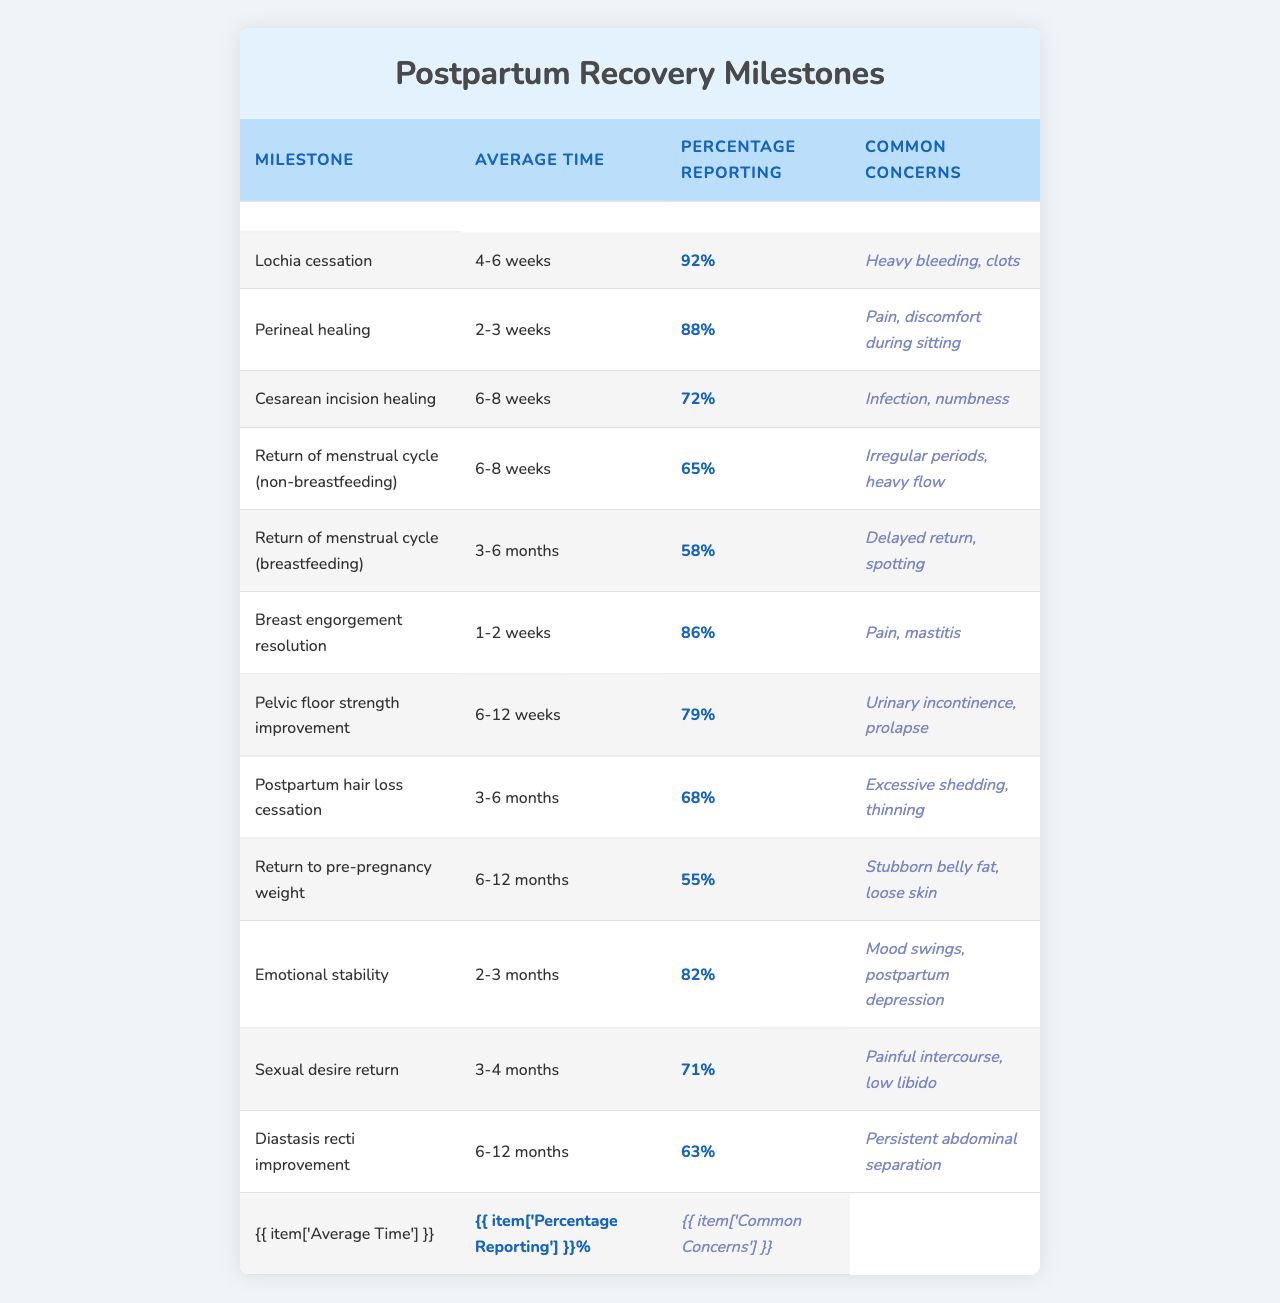What is the average time for Lochia cessation? The table lists the average time for Lochia cessation as "4-6 weeks."
Answer: 4-6 weeks What percentage of mothers report concerns of heavy bleeding and clots during Lochia cessation? According to the table, 92% of mothers reported concerns related to heavy bleeding and clots during Lochia cessation.
Answer: 92% Which postpartum milestone has the lowest percentage of mothers reporting it? By examining the percentages in the table, "Return to pre-pregnancy weight" has the lowest reporting percentage at 55%.
Answer: 55% How does the average time for perineal healing compare to the average time for cesarean incision healing? The average time for perineal healing is 2-3 weeks, while for cesarean incision healing it is 6-8 weeks. Therefore, cesarean incision healing takes longer on average by at least 4 weeks.
Answer: Perineal healing is shorter What are the common concerns associated with the return of menstrual cycles for breastfeeding mothers? The table states that common concerns for breastfeeding mothers returning to their menstrual cycle include "Delayed return, spotting."
Answer: Delayed return, spotting Is there a higher percentage of mothers reporting concerns for emotional stability or pelvic floor strength improvement? For emotional stability, 82% reported concerns, and for pelvic floor strength improvement, it is 79%. Thus, more mothers reported concerns for emotional stability.
Answer: Emotional stability Calculate the average percentage of mothers reporting concerns for the return of menstrual cycles (breastfeeding and non-breastfeeding). The return of menstrual cycle (non-breastfeeding) reports 65%, and breastfeeding reports 58%. Therefore, their average is (65 + 58) / 2 = 61.5%.
Answer: 61.5% True or False: More than 70% of mothers reported concerns for breast engorgement resolution. The table shows that 86% of mothers reported concerns for breast engorgement resolution, which is more than 70%.
Answer: True What is the time frame in which most transitions from postpartum hair loss cessation occur? The table indicates that most mothers experience postpartum hair loss cessation in 3-6 months, which is the reported average time.
Answer: 3-6 months Which postpartum milestone has a reporting percentage closest to 70%? "Return of menstrual cycle (breastfeeding)" has a reporting percentage of 58%, and "Cesarean incision healing" has a percentage of 72%. The latter is closest to 70%.
Answer: Cesarean incision healing What is the range of average times for pelvic floor strength improvement? The table shows the average time for pelvic floor strength improvement is between 6-12 weeks, indicating a range of weeks.
Answer: 6-12 weeks 